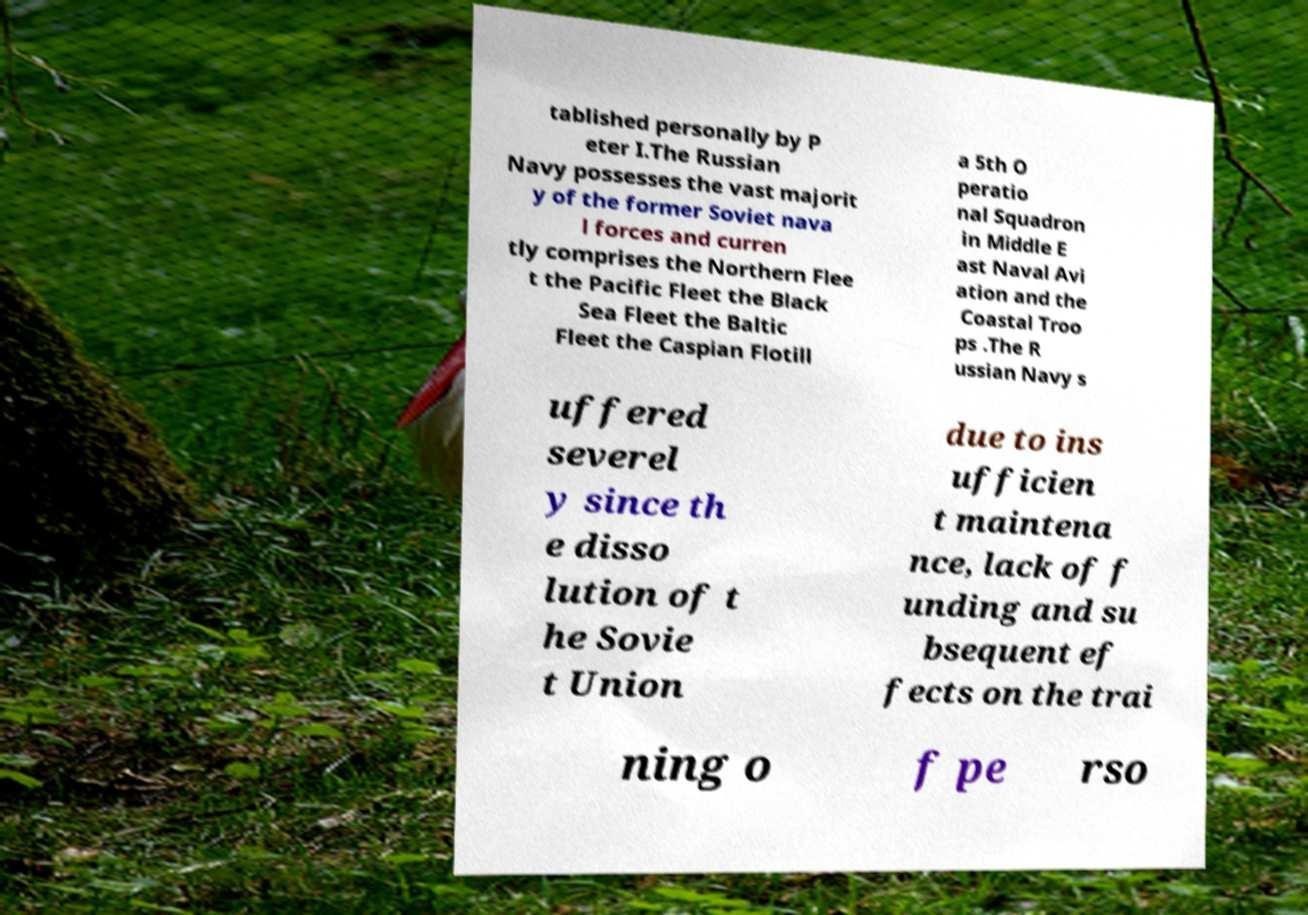I need the written content from this picture converted into text. Can you do that? tablished personally by P eter I.The Russian Navy possesses the vast majorit y of the former Soviet nava l forces and curren tly comprises the Northern Flee t the Pacific Fleet the Black Sea Fleet the Baltic Fleet the Caspian Flotill a 5th O peratio nal Squadron in Middle E ast Naval Avi ation and the Coastal Troo ps .The R ussian Navy s uffered severel y since th e disso lution of t he Sovie t Union due to ins ufficien t maintena nce, lack of f unding and su bsequent ef fects on the trai ning o f pe rso 